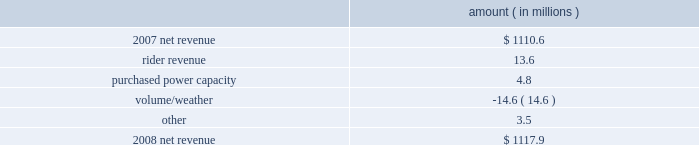Entergy arkansas , inc .
Management's financial discussion and analysis results of operations net income 2008 compared to 2007 net income decreased $ 92.0 million primarily due to higher other operation and maintenance expenses , higher depreciation and amortization expenses , and a higher effective income tax rate , partially offset by higher net revenue .
The higher other operation and maintenance expenses resulted primarily from the write-off of approximately $ 70.8 million of costs as a result of the december 2008 arkansas court of appeals decision in entergy arkansas' base rate case .
The base rate case is discussed in more detail in note 2 to the financial statements .
2007 compared to 2006 net income decreased $ 34.0 million primarily due to higher other operation and maintenance expenses , higher depreciation and amortization expenses , and a higher effective income tax rate .
The decrease was partially offset by higher net revenue .
Net revenue 2008 compared to 2007 net revenue consists of operating revenues net of : 1 ) fuel , fuel-related expenses , and gas purchased for resale , 2 ) purchased power expenses , and 3 ) other regulatory credits .
Following is an analysis of the change in net revenue comparing 2008 to 2007 .
Amount ( in millions ) .
The rider revenue variance is primarily due to an energy efficiency rider which became effective in november 2007 .
The establishment of the rider results in an increase in rider revenue and a corresponding increase in other operation and maintenance expense with no effect on net income .
Also contributing to the variance was an increase in franchise tax rider revenue as a result of higher retail revenues .
The corresponding increase is in taxes other than income taxes , resulting in no effect on net income .
The purchased power capacity variance is primarily due to lower reserve equalization expenses .
The volume/weather variance is primarily due to the effect of less favorable weather on residential and commercial sales during the billed and unbilled sales periods compared to 2007 and a 2.9% ( 2.9 % ) volume decrease in industrial sales , primarily in the wood industry and the small customer class .
Billed electricity usage decreased 333 gwh in all sectors .
See "critical accounting estimates" below and note 1 to the financial statements for further discussion of the accounting for unbilled revenues. .
What is the net change in net revenue during 2008 for entergy arkansas? 
Computations: (1117.9 - 1110.6)
Answer: 7.3. 